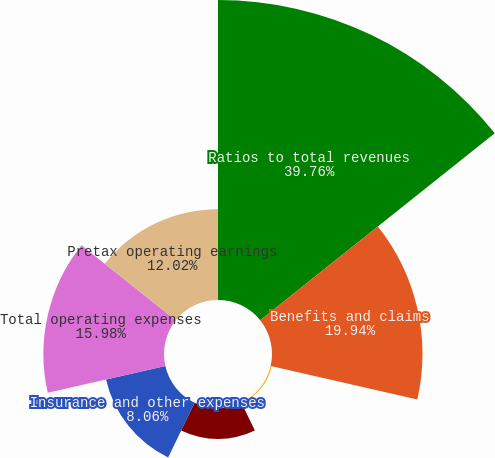Convert chart to OTSL. <chart><loc_0><loc_0><loc_500><loc_500><pie_chart><fcel>Ratios to total revenues<fcel>Benefits and claims<fcel>Amortization of deferred<fcel>Insurance commissions<fcel>Insurance and other expenses<fcel>Total operating expenses<fcel>Pretax operating earnings<nl><fcel>39.75%<fcel>19.94%<fcel>0.14%<fcel>4.1%<fcel>8.06%<fcel>15.98%<fcel>12.02%<nl></chart> 